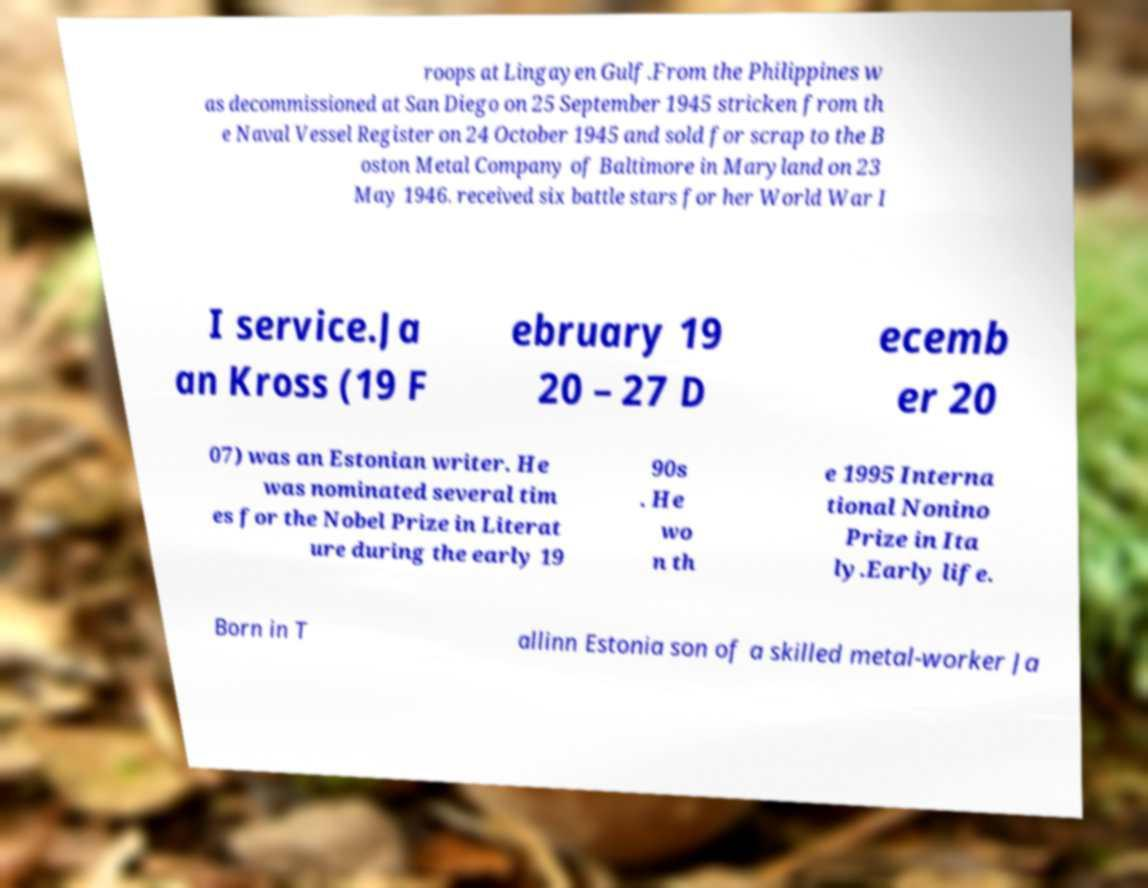I need the written content from this picture converted into text. Can you do that? roops at Lingayen Gulf.From the Philippines w as decommissioned at San Diego on 25 September 1945 stricken from th e Naval Vessel Register on 24 October 1945 and sold for scrap to the B oston Metal Company of Baltimore in Maryland on 23 May 1946. received six battle stars for her World War I I service.Ja an Kross (19 F ebruary 19 20 – 27 D ecemb er 20 07) was an Estonian writer. He was nominated several tim es for the Nobel Prize in Literat ure during the early 19 90s . He wo n th e 1995 Interna tional Nonino Prize in Ita ly.Early life. Born in T allinn Estonia son of a skilled metal-worker Ja 